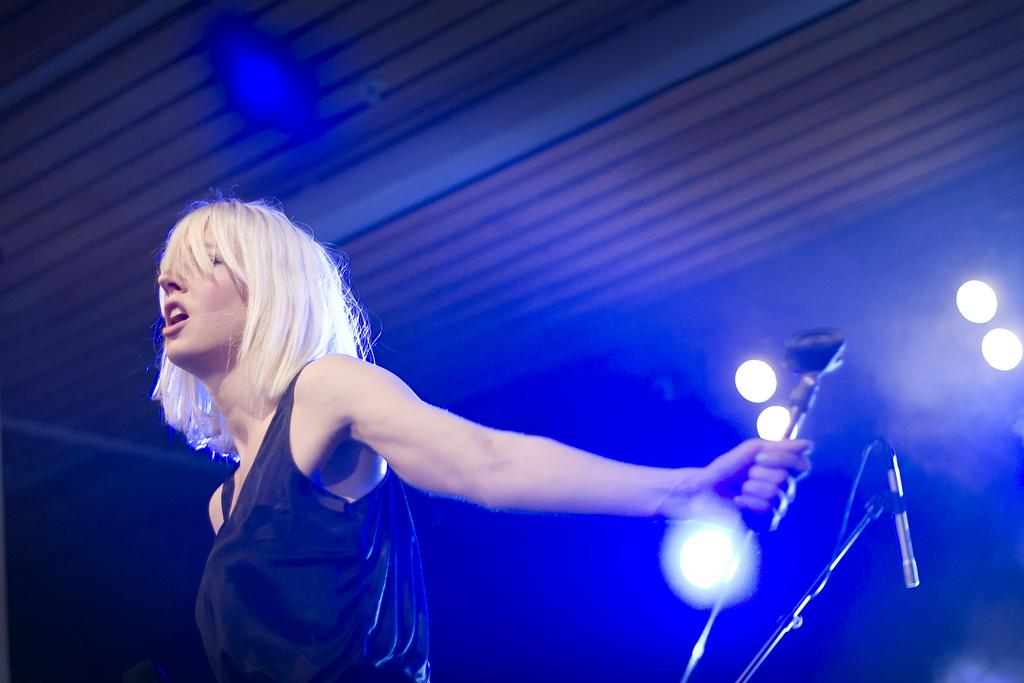Who is the main subject in the foreground of the picture? There is a woman in the foreground of the picture. What is the woman wearing in the image? The woman is wearing a black dress. What is the woman holding in the image? The woman is holding a microphone. What can be seen in the background of the picture? There are focus lights in the background of the picture. What type of library can be seen in the background of the image? There is no library present in the image; the background features focus lights. Is there a canvas visible in the image? There is no canvas present in the image. 